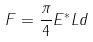Convert formula to latex. <formula><loc_0><loc_0><loc_500><loc_500>F = \frac { \pi } { 4 } E ^ { * } L d</formula> 